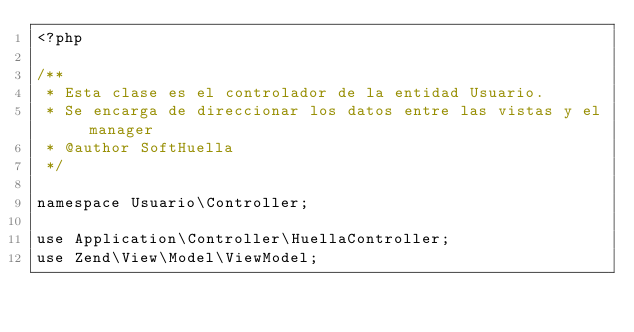Convert code to text. <code><loc_0><loc_0><loc_500><loc_500><_PHP_><?php

/**
 * Esta clase es el controlador de la entidad Usuario.  
 * Se encarga de direccionar los datos entre las vistas y el manager
 * @author SoftHuella 
 */

namespace Usuario\Controller;

use Application\Controller\HuellaController;
use Zend\View\Model\ViewModel;</code> 